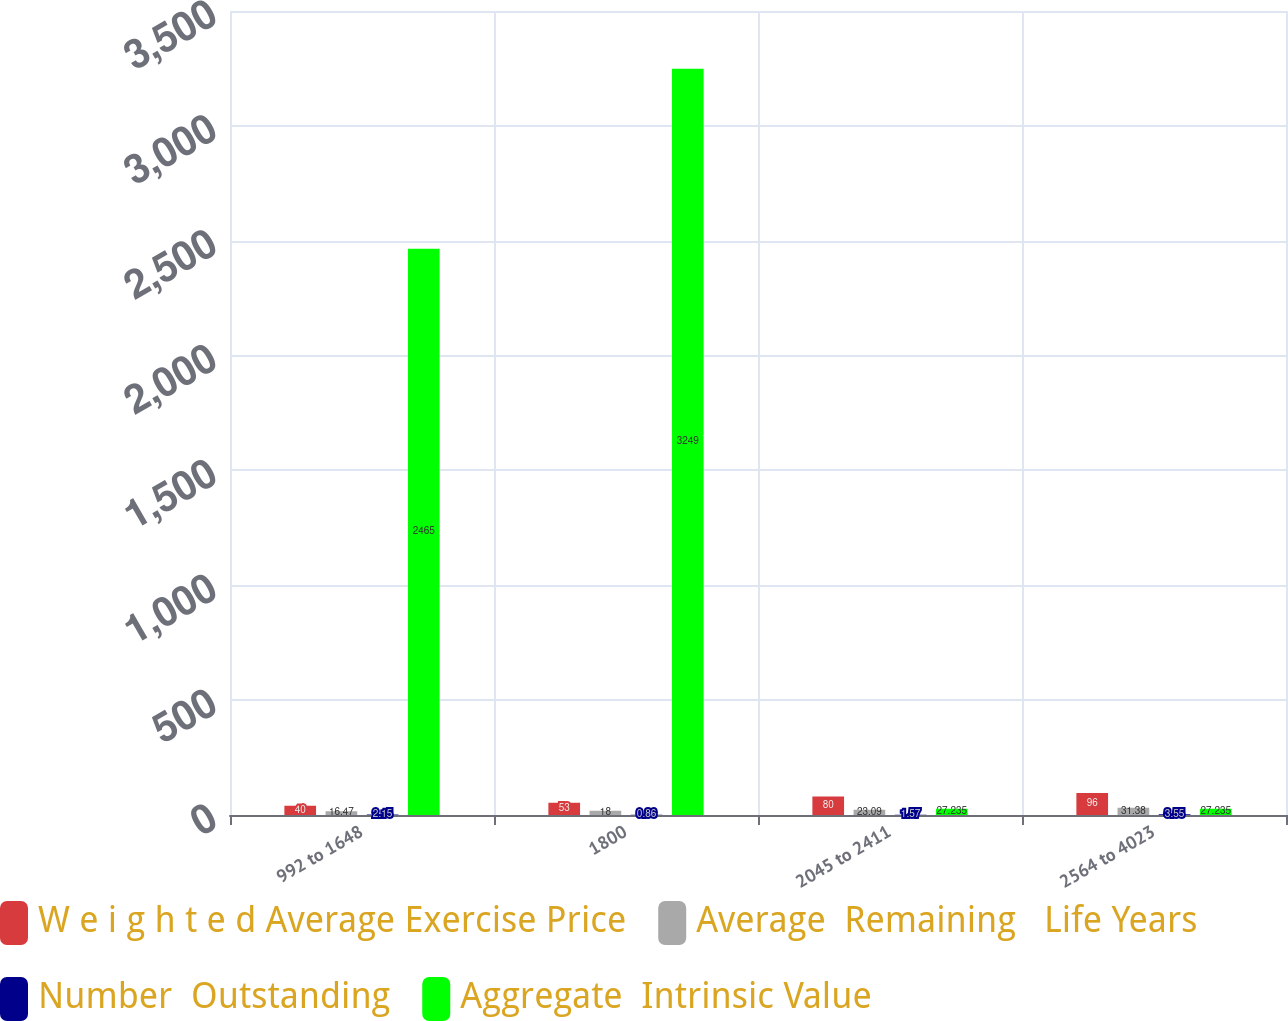<chart> <loc_0><loc_0><loc_500><loc_500><stacked_bar_chart><ecel><fcel>992 to 1648<fcel>1800<fcel>2045 to 2411<fcel>2564 to 4023<nl><fcel>W e i g h t e d Average Exercise Price<fcel>40<fcel>53<fcel>80<fcel>96<nl><fcel>Average  Remaining   Life Years<fcel>16.47<fcel>18<fcel>23.09<fcel>31.38<nl><fcel>Number  Outstanding<fcel>2.15<fcel>0.86<fcel>1.57<fcel>3.55<nl><fcel>Aggregate  Intrinsic Value<fcel>2465<fcel>3249<fcel>27.235<fcel>27.235<nl></chart> 